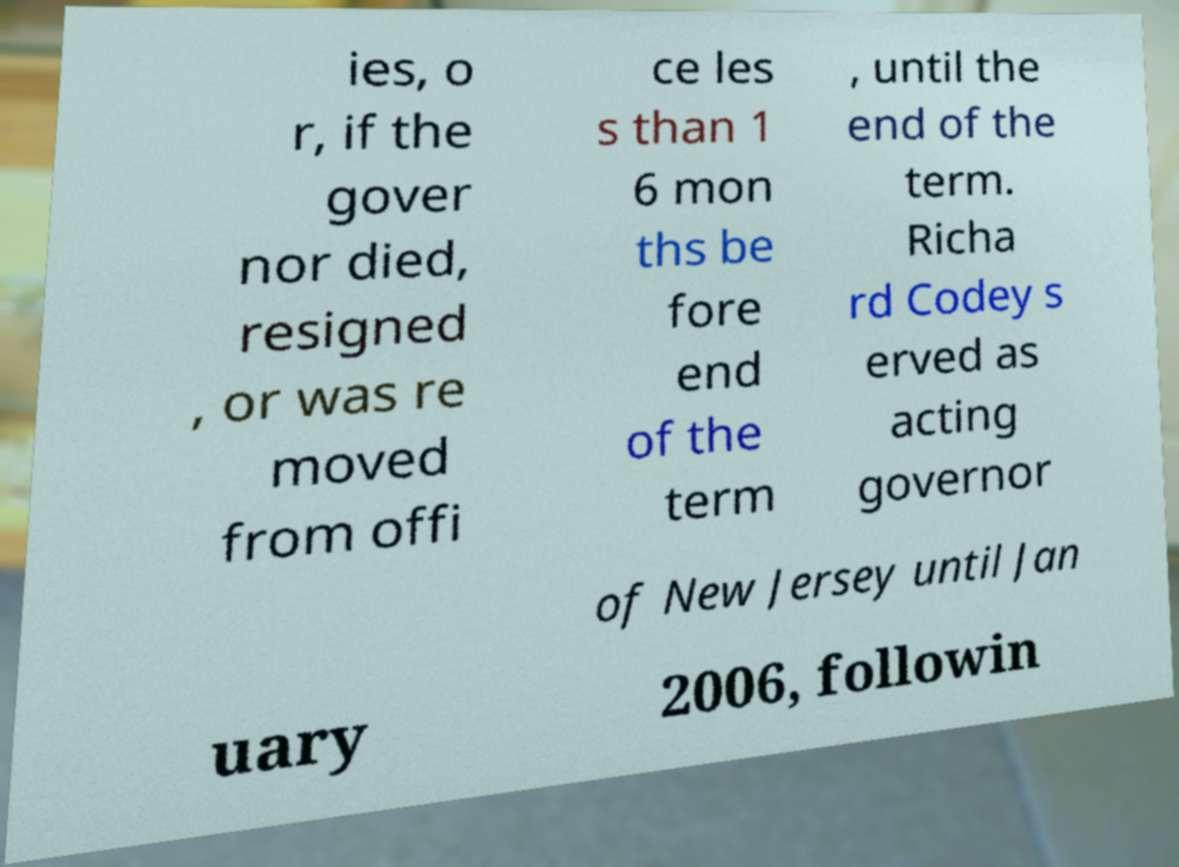Please identify and transcribe the text found in this image. ies, o r, if the gover nor died, resigned , or was re moved from offi ce les s than 1 6 mon ths be fore end of the term , until the end of the term. Richa rd Codey s erved as acting governor of New Jersey until Jan uary 2006, followin 